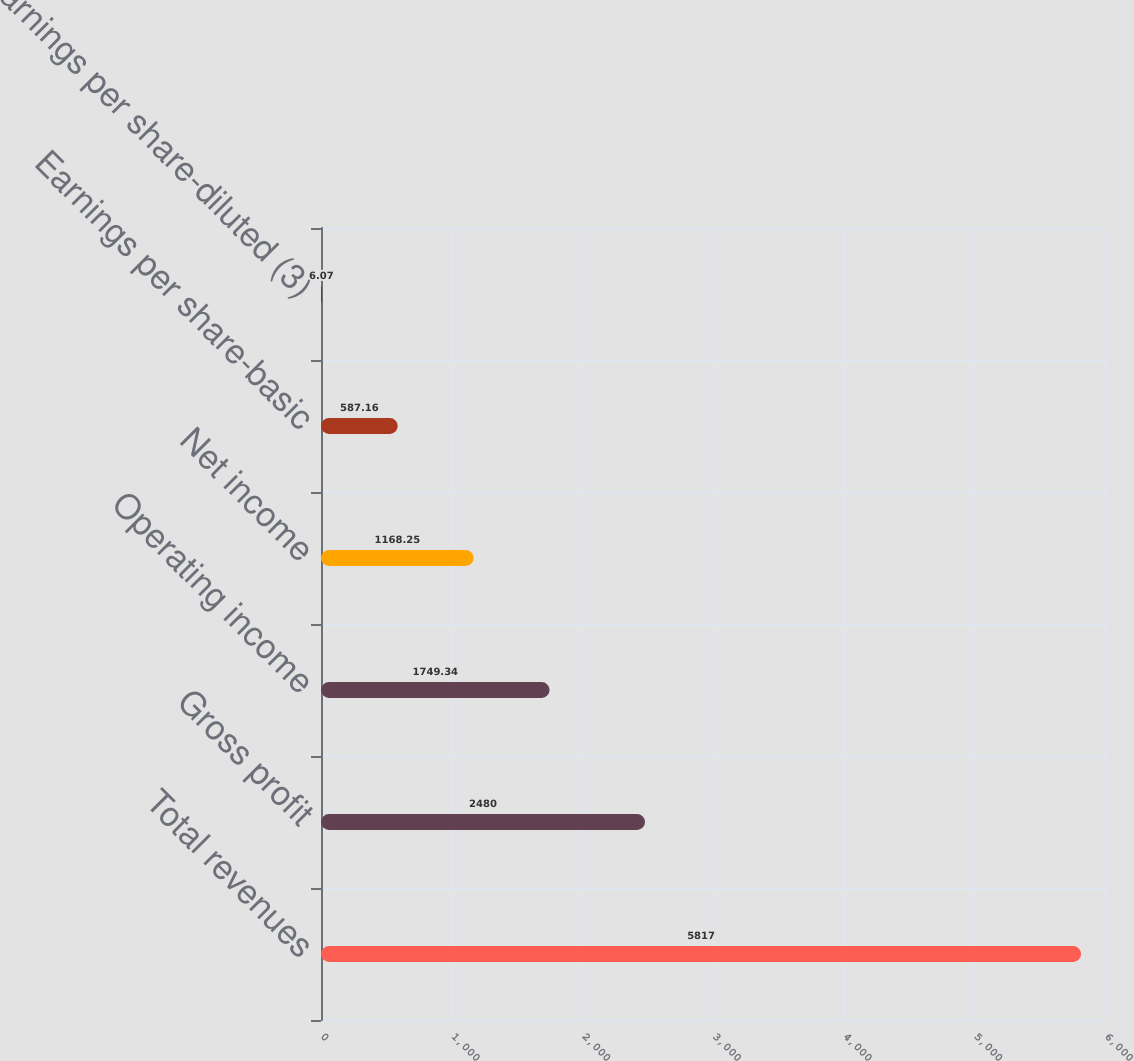Convert chart. <chart><loc_0><loc_0><loc_500><loc_500><bar_chart><fcel>Total revenues<fcel>Gross profit<fcel>Operating income<fcel>Net income<fcel>Earnings per share-basic<fcel>Earnings per share-diluted (3)<nl><fcel>5817<fcel>2480<fcel>1749.34<fcel>1168.25<fcel>587.16<fcel>6.07<nl></chart> 